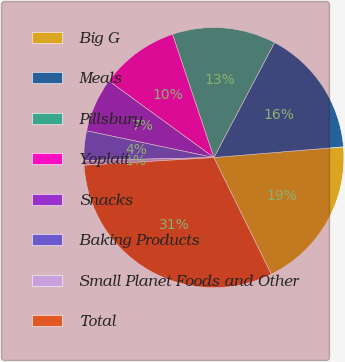<chart> <loc_0><loc_0><loc_500><loc_500><pie_chart><fcel>Big G<fcel>Meals<fcel>Pillsbury<fcel>Yoplait<fcel>Snacks<fcel>Baking Products<fcel>Small Planet Foods and Other<fcel>Total<nl><fcel>19.03%<fcel>15.96%<fcel>12.88%<fcel>9.81%<fcel>6.73%<fcel>3.66%<fcel>0.58%<fcel>31.33%<nl></chart> 